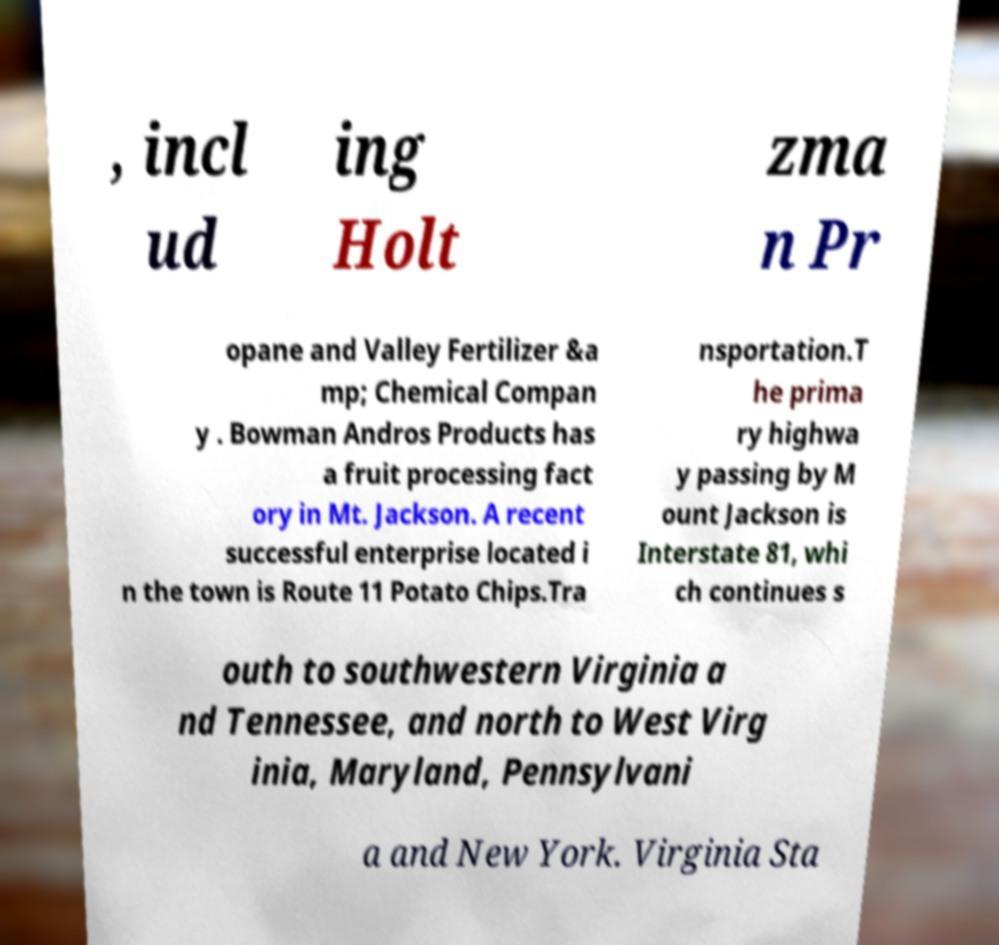For documentation purposes, I need the text within this image transcribed. Could you provide that? , incl ud ing Holt zma n Pr opane and Valley Fertilizer &a mp; Chemical Compan y . Bowman Andros Products has a fruit processing fact ory in Mt. Jackson. A recent successful enterprise located i n the town is Route 11 Potato Chips.Tra nsportation.T he prima ry highwa y passing by M ount Jackson is Interstate 81, whi ch continues s outh to southwestern Virginia a nd Tennessee, and north to West Virg inia, Maryland, Pennsylvani a and New York. Virginia Sta 